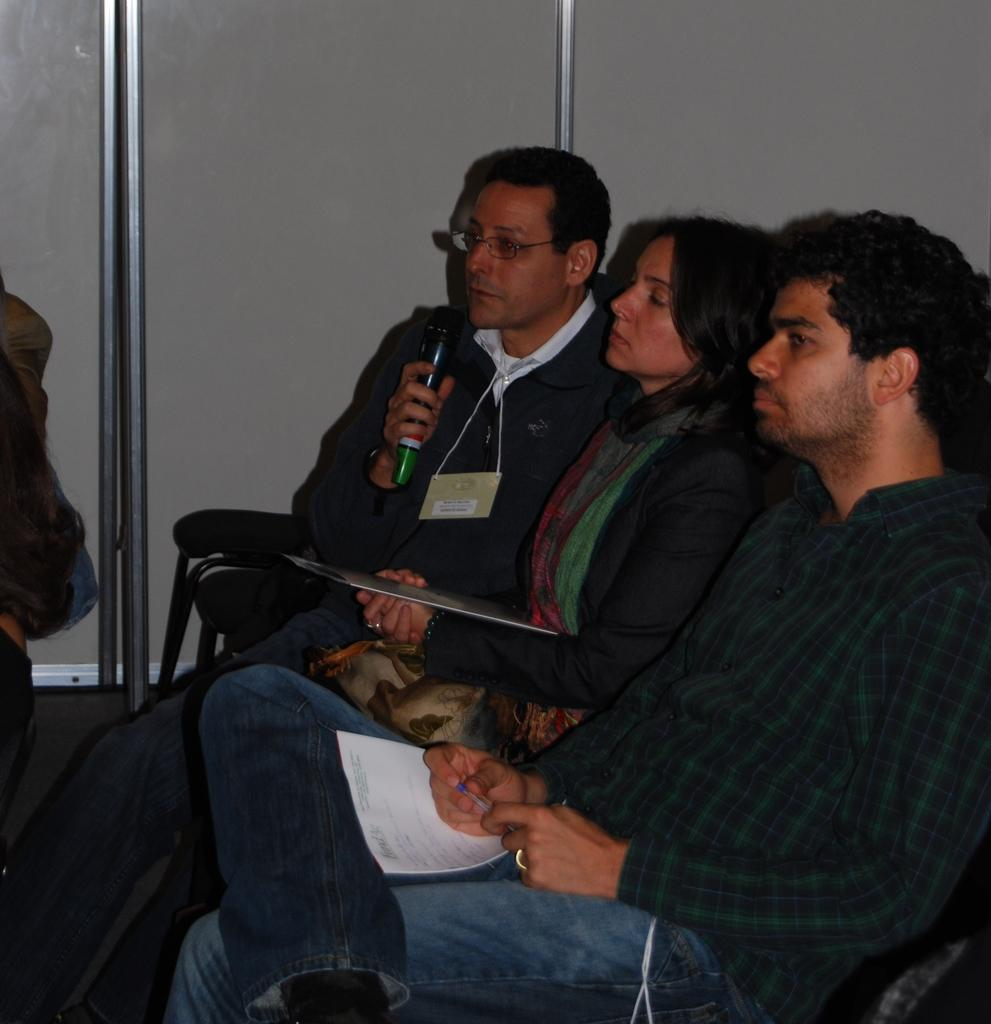What are the people in the image doing? The people in the image are sitting on chairs. Can you describe any specific actions or objects being held by the people? One person is holding a microphone, and some people are holding papers. What type of wall can be seen in the image? There is a wooden wall in the image. What type of writer is present in the image? There is no writer present in the image. Can you tell me how many water bottles are visible in the image? There is no mention of water bottles in the image, so it cannot be determined how many are visible. 